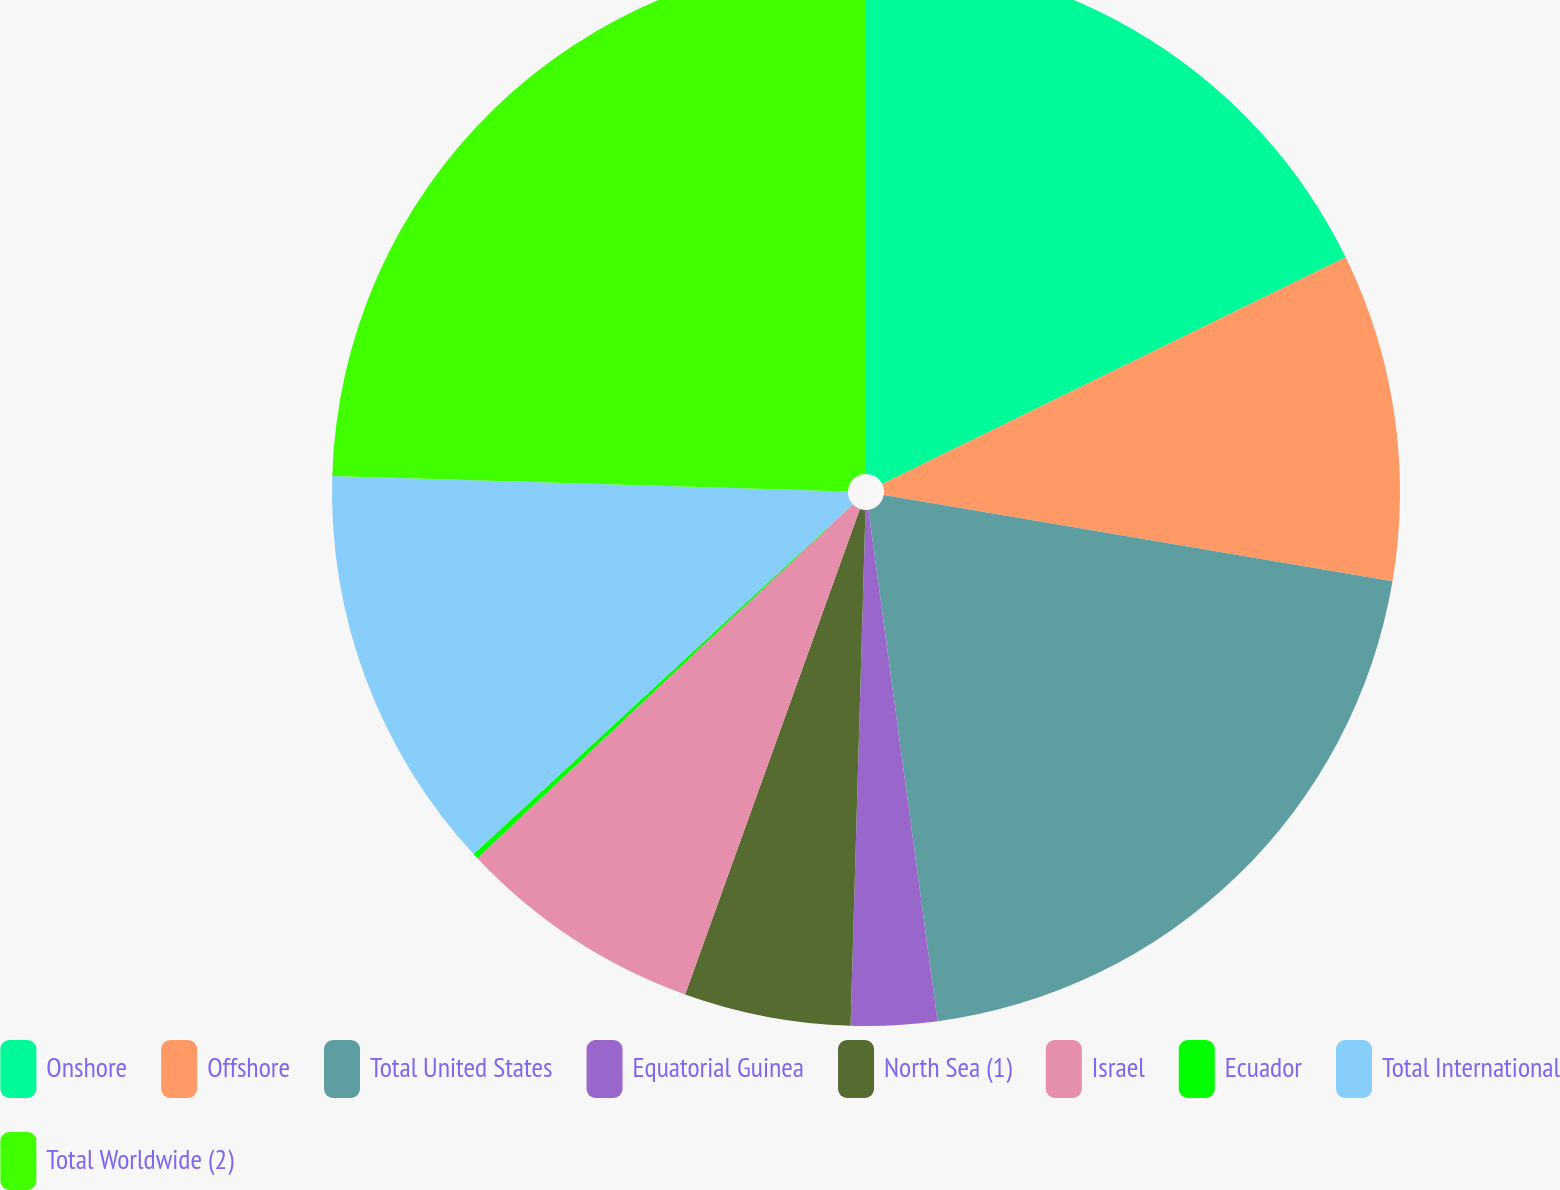<chart> <loc_0><loc_0><loc_500><loc_500><pie_chart><fcel>Onshore<fcel>Offshore<fcel>Total United States<fcel>Equatorial Guinea<fcel>North Sea (1)<fcel>Israel<fcel>Ecuador<fcel>Total International<fcel>Total Worldwide (2)<nl><fcel>17.76%<fcel>9.91%<fcel>20.19%<fcel>2.6%<fcel>5.04%<fcel>7.47%<fcel>0.17%<fcel>12.34%<fcel>24.52%<nl></chart> 